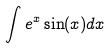<formula> <loc_0><loc_0><loc_500><loc_500>\int e ^ { x } \sin ( x ) d x</formula> 